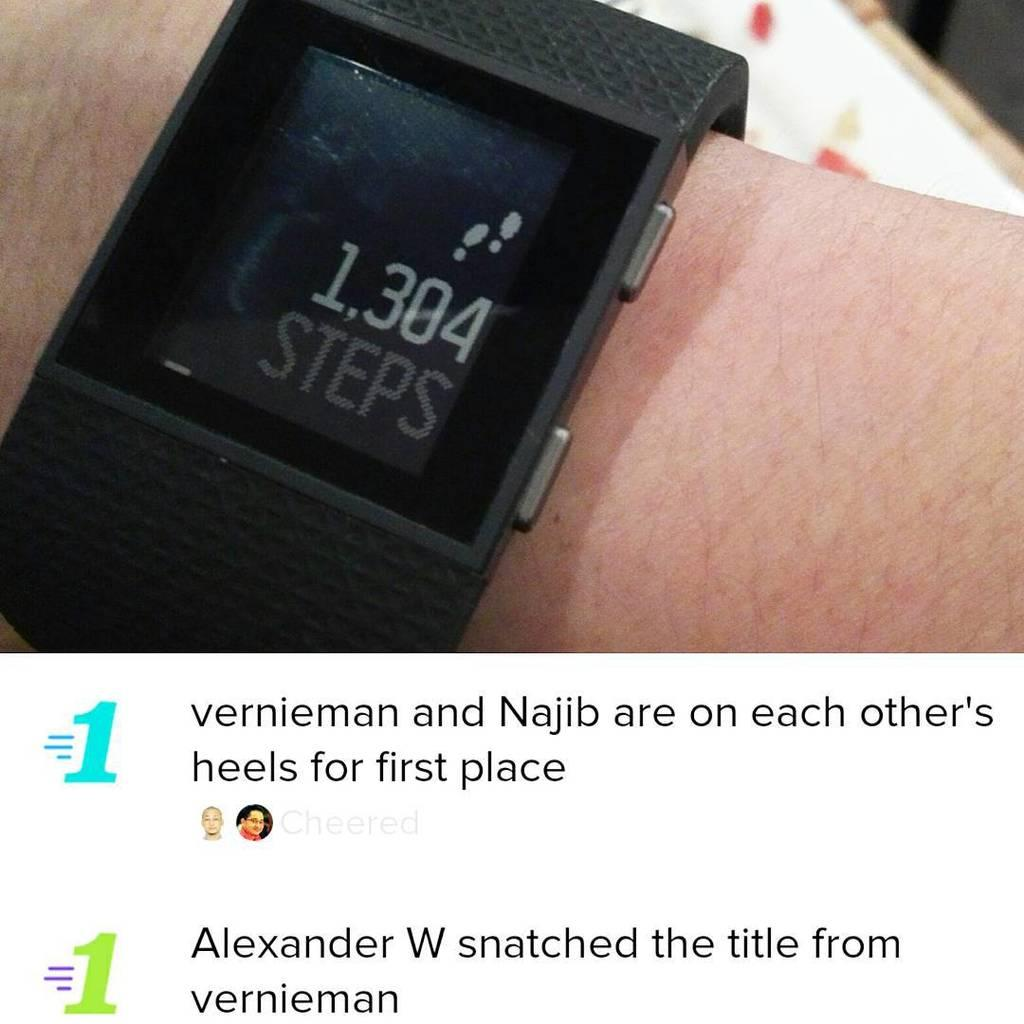<image>
Provide a brief description of the given image. a watch that has the word steps on it 